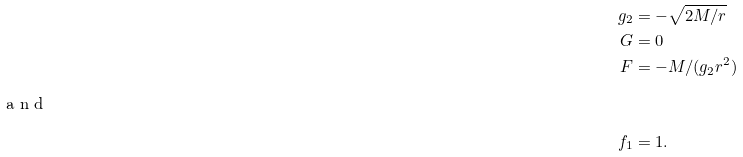Convert formula to latex. <formula><loc_0><loc_0><loc_500><loc_500>g _ { 2 } & = - \sqrt { 2 M / r } \\ G & = 0 \\ F & = - M / ( g _ { 2 } r ^ { 2 } ) \\ \intertext { a n d } f _ { 1 } & = 1 .</formula> 